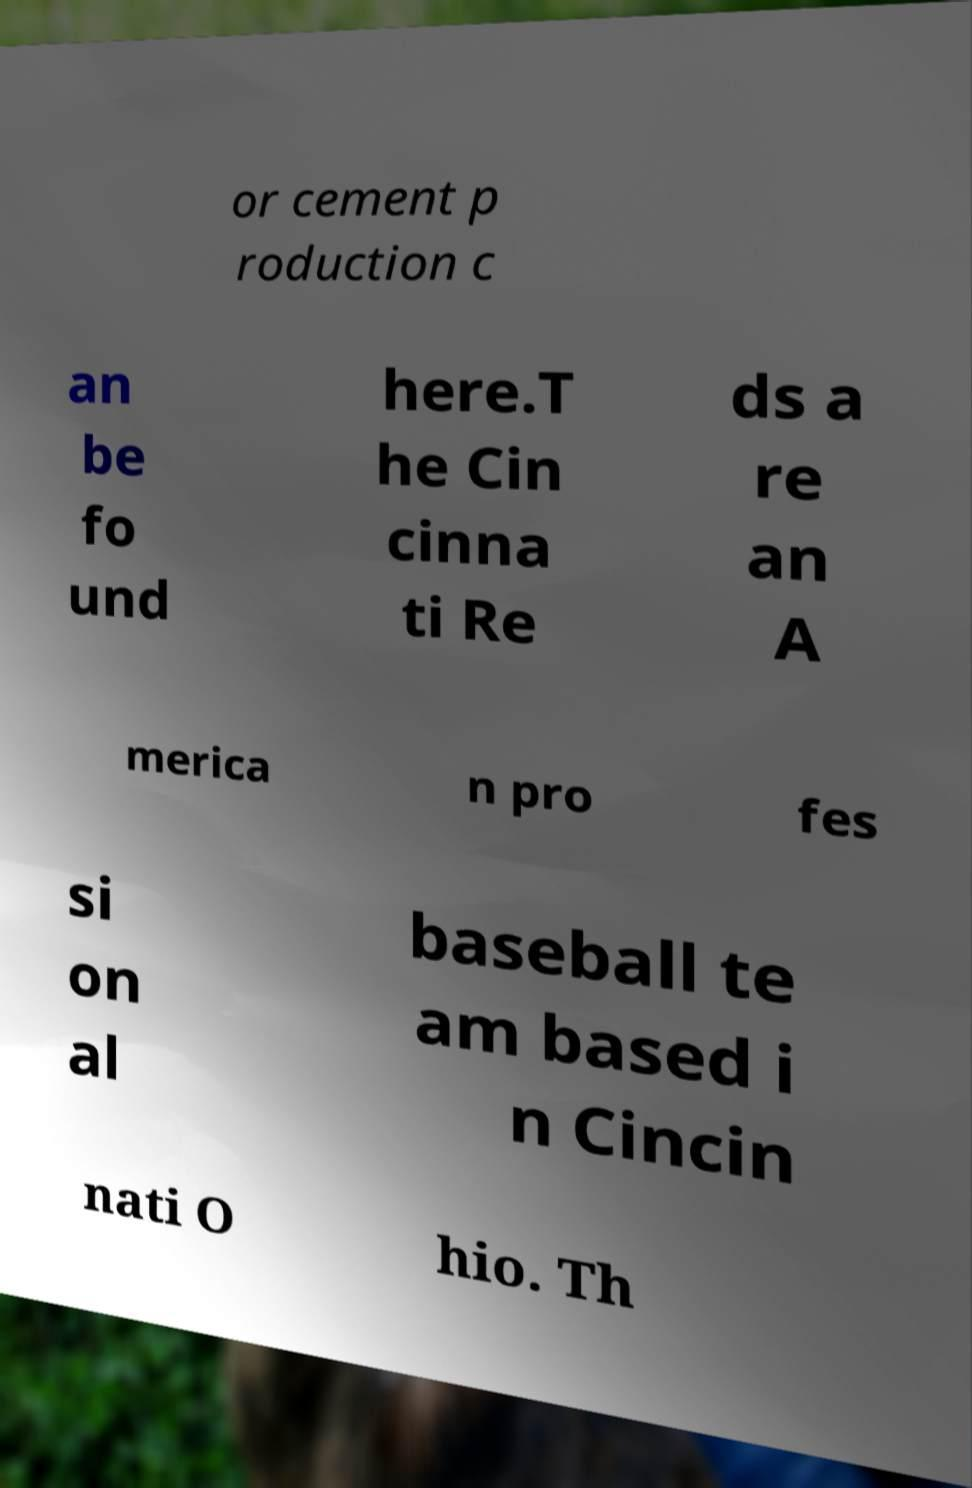Can you read and provide the text displayed in the image?This photo seems to have some interesting text. Can you extract and type it out for me? or cement p roduction c an be fo und here.T he Cin cinna ti Re ds a re an A merica n pro fes si on al baseball te am based i n Cincin nati O hio. Th 